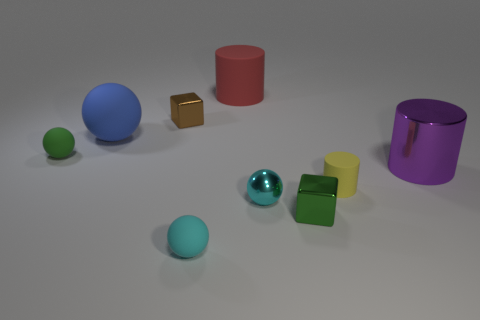Subtract 1 spheres. How many spheres are left? 3 Add 1 cubes. How many objects exist? 10 Subtract all cubes. How many objects are left? 7 Add 3 brown shiny things. How many brown shiny things are left? 4 Add 4 green cylinders. How many green cylinders exist? 4 Subtract 1 cyan balls. How many objects are left? 8 Subtract all small brown metallic cubes. Subtract all tiny rubber things. How many objects are left? 5 